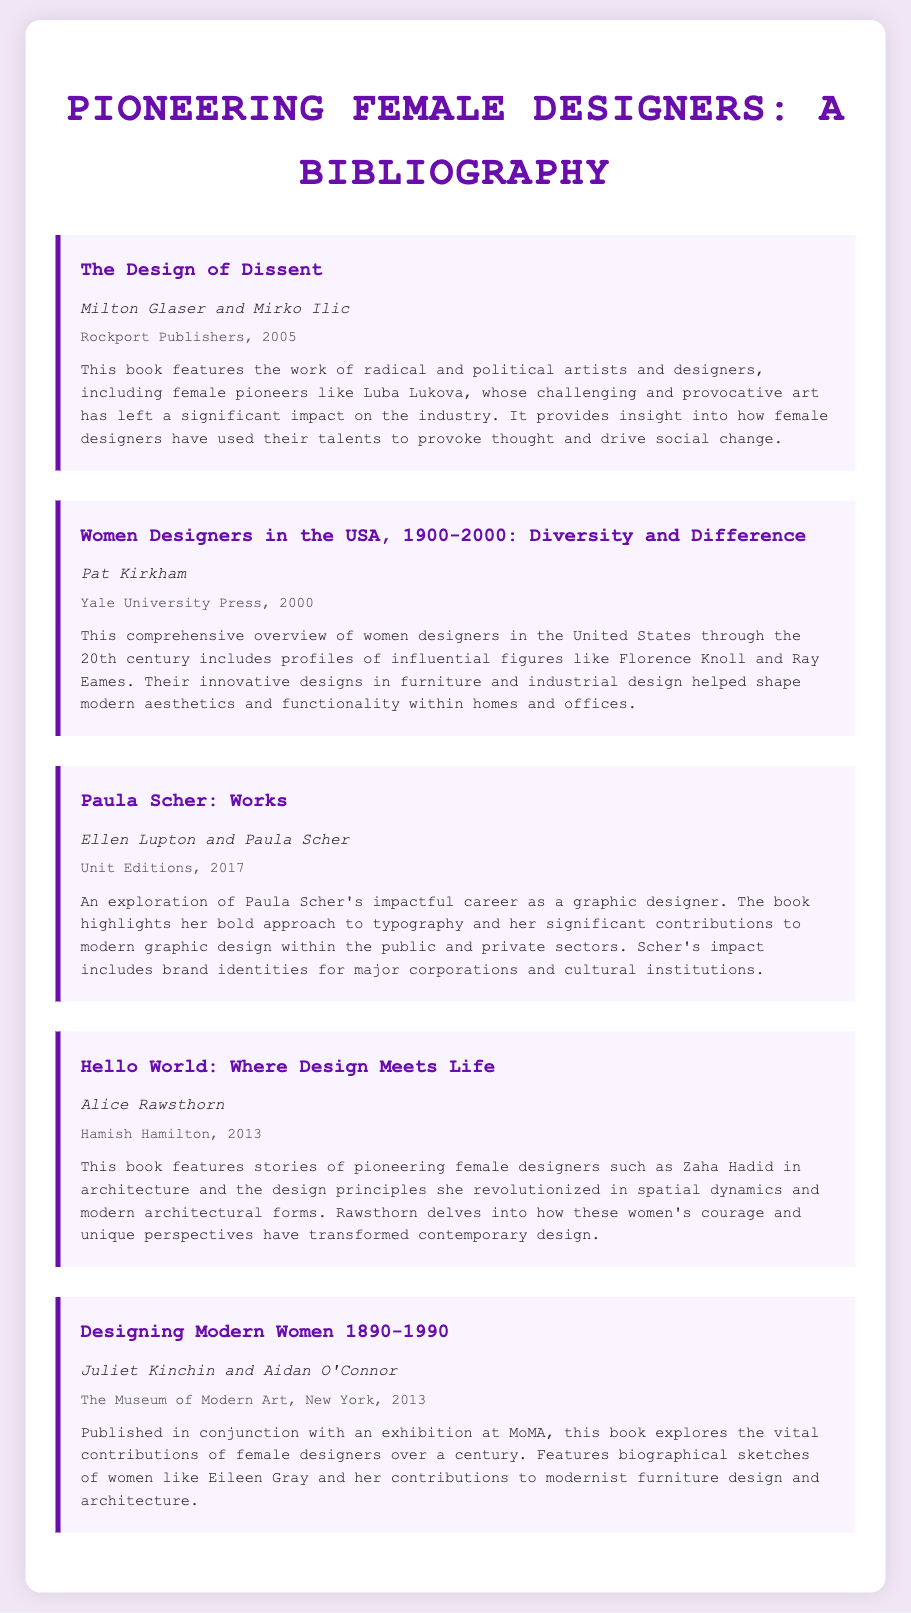What is the title of the first book? The title of the first book listed in the bibliography is "The Design of Dissent."
Answer: The Design of Dissent Who are the authors of "Women Designers in the USA, 1900-2000"? The authors of this book are Pat Kirkham.
Answer: Pat Kirkham In what year was "Paula Scher: Works" published? The book "Paula Scher: Works" was published in 2017.
Answer: 2017 Which female designer is highlighted in "Hello World: Where Design Meets Life"? The book highlights Zaha Hadid as a pioneering female designer.
Answer: Zaha Hadid What kind of designers does "Designing Modern Women 1890-1990" focus on? This book focuses on female designers and their contributions.
Answer: Female designers How many books in the document feature the names of authors? All five books listed in the bibliography feature names of authors.
Answer: Five 